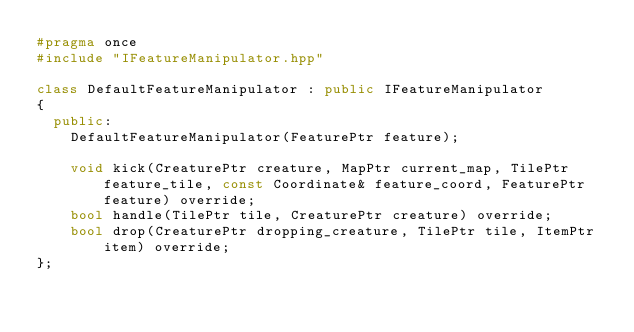<code> <loc_0><loc_0><loc_500><loc_500><_C++_>#pragma once
#include "IFeatureManipulator.hpp"

class DefaultFeatureManipulator : public IFeatureManipulator
{
  public:
    DefaultFeatureManipulator(FeaturePtr feature);

    void kick(CreaturePtr creature, MapPtr current_map, TilePtr feature_tile, const Coordinate& feature_coord, FeaturePtr feature) override;
    bool handle(TilePtr tile, CreaturePtr creature) override;
    bool drop(CreaturePtr dropping_creature, TilePtr tile, ItemPtr item) override;
};

</code> 